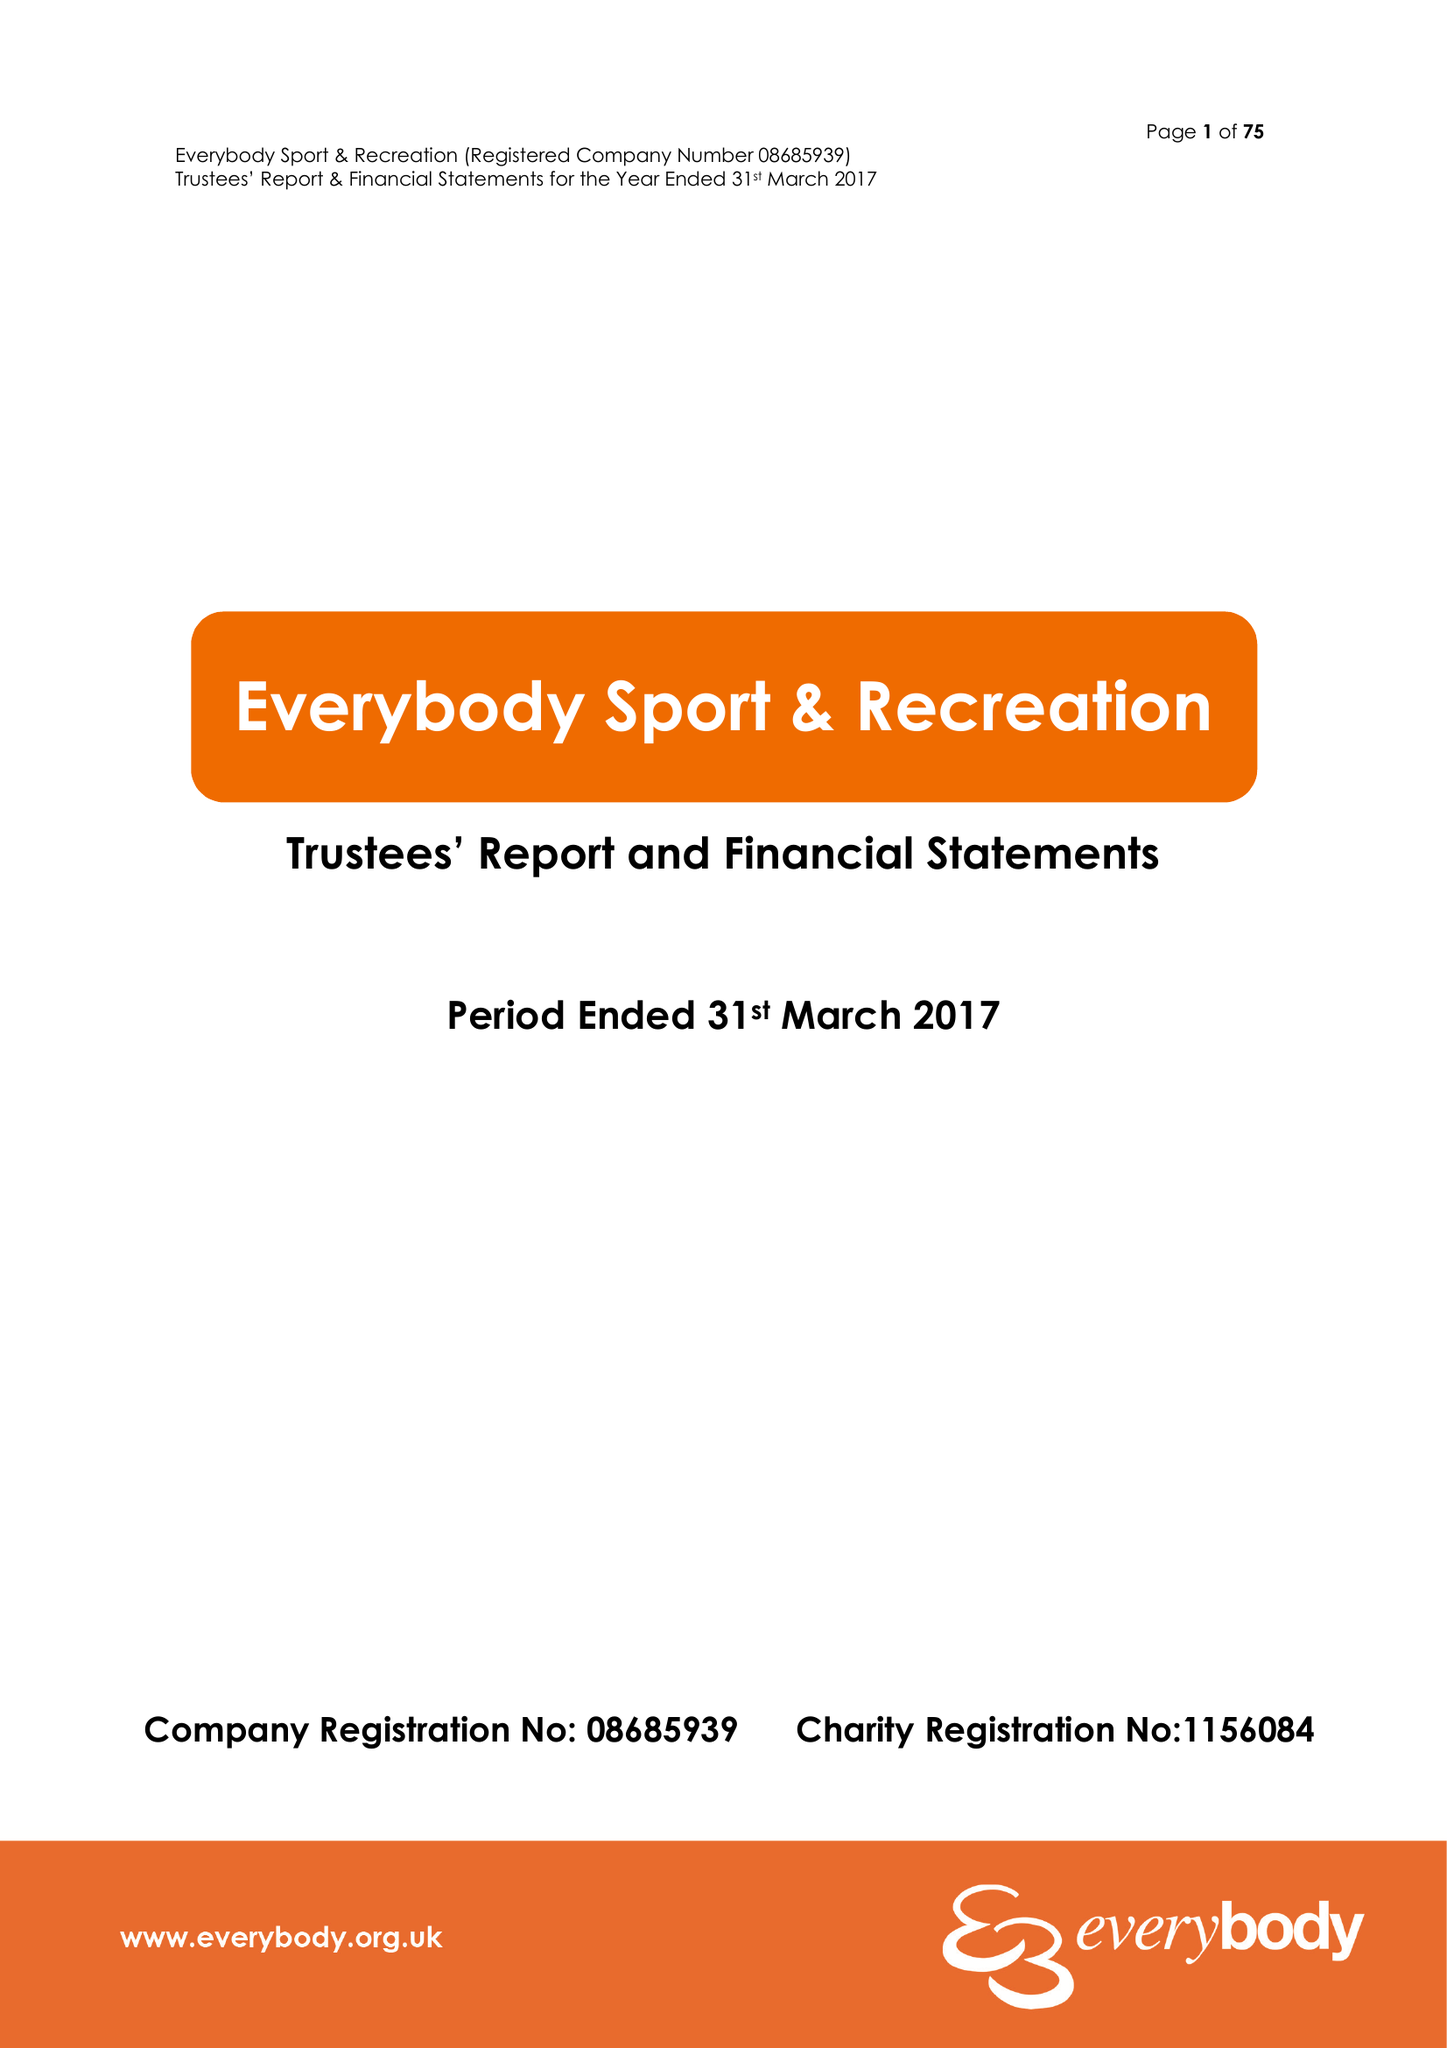What is the value for the income_annually_in_british_pounds?
Answer the question using a single word or phrase. 14821232.00 